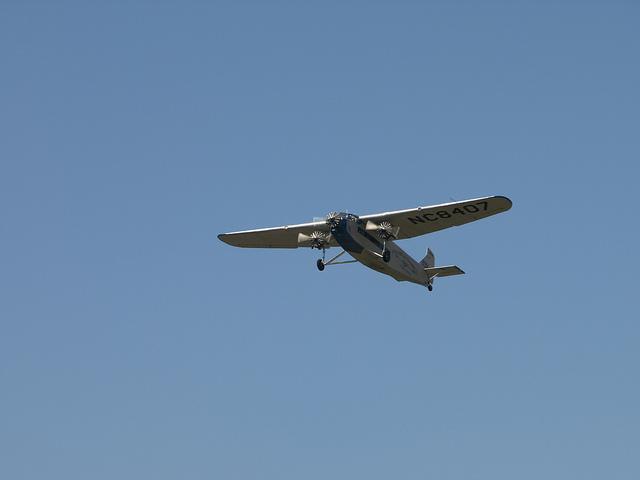How many orange cats are there in the image?
Give a very brief answer. 0. 